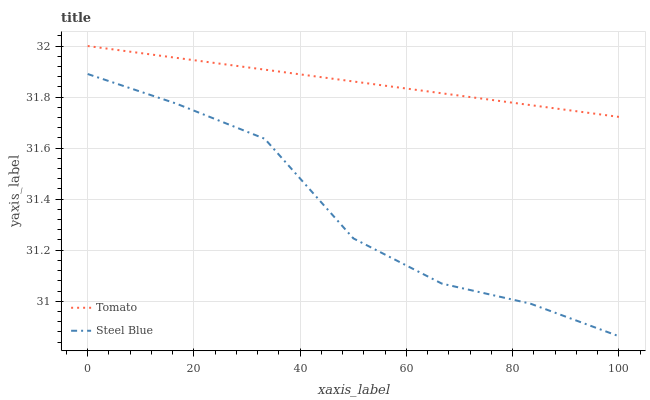Does Steel Blue have the minimum area under the curve?
Answer yes or no. Yes. Does Tomato have the maximum area under the curve?
Answer yes or no. Yes. Does Steel Blue have the maximum area under the curve?
Answer yes or no. No. Is Tomato the smoothest?
Answer yes or no. Yes. Is Steel Blue the roughest?
Answer yes or no. Yes. Is Steel Blue the smoothest?
Answer yes or no. No. Does Steel Blue have the lowest value?
Answer yes or no. Yes. Does Tomato have the highest value?
Answer yes or no. Yes. Does Steel Blue have the highest value?
Answer yes or no. No. Is Steel Blue less than Tomato?
Answer yes or no. Yes. Is Tomato greater than Steel Blue?
Answer yes or no. Yes. Does Steel Blue intersect Tomato?
Answer yes or no. No. 